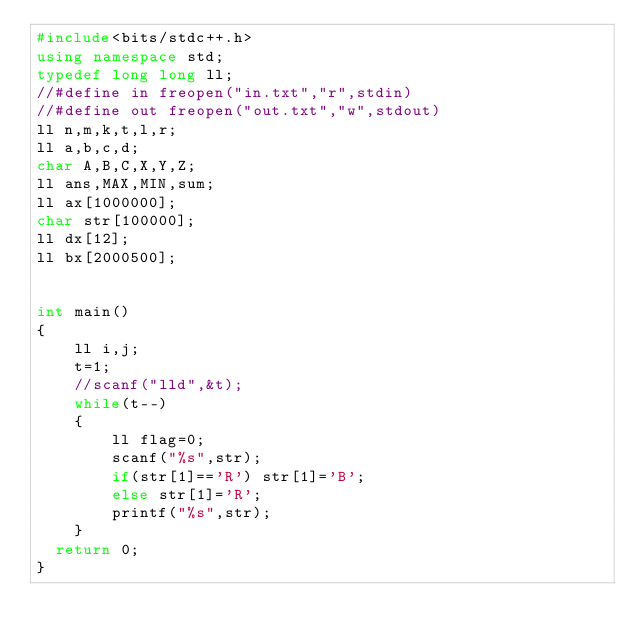Convert code to text. <code><loc_0><loc_0><loc_500><loc_500><_C++_>#include<bits/stdc++.h>
using namespace std;
typedef long long ll;
//#define in freopen("in.txt","r",stdin)
//#define out freopen("out.txt","w",stdout) 
ll n,m,k,t,l,r;
ll a,b,c,d;
char A,B,C,X,Y,Z;
ll ans,MAX,MIN,sum;
ll ax[1000000];
char str[100000];
ll dx[12];
ll bx[2000500];


int main()
{
    ll i,j;
    t=1;
    //scanf("lld",&t);
    while(t--)
    {
        ll flag=0;
        scanf("%s",str);
        if(str[1]=='R') str[1]='B';
        else str[1]='R';
        printf("%s",str);
    }
	return 0;
}</code> 